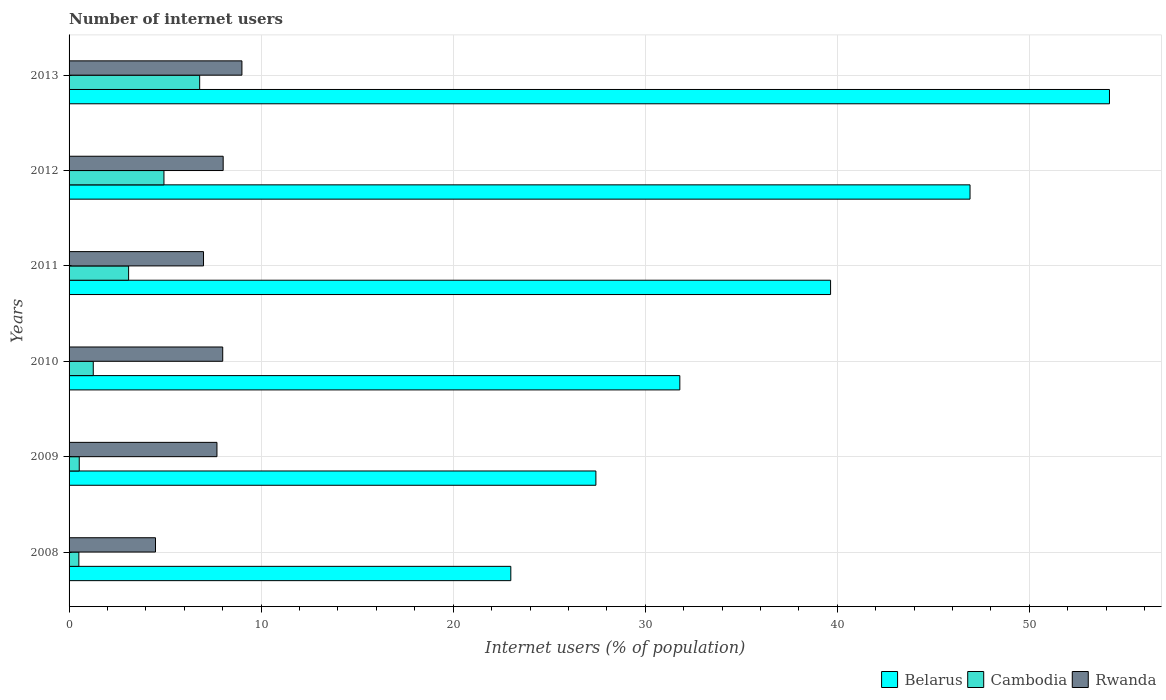How many groups of bars are there?
Provide a succinct answer. 6. Are the number of bars per tick equal to the number of legend labels?
Offer a very short reply. Yes. Are the number of bars on each tick of the Y-axis equal?
Give a very brief answer. Yes. What is the label of the 2nd group of bars from the top?
Offer a very short reply. 2012. What is the number of internet users in Belarus in 2008?
Provide a short and direct response. 23. Across all years, what is the maximum number of internet users in Cambodia?
Your answer should be very brief. 6.8. Across all years, what is the minimum number of internet users in Rwanda?
Give a very brief answer. 4.5. In which year was the number of internet users in Cambodia maximum?
Make the answer very short. 2013. What is the total number of internet users in Cambodia in the graph?
Ensure brevity in your answer.  17.14. What is the difference between the number of internet users in Cambodia in 2009 and that in 2013?
Offer a terse response. -6.27. What is the difference between the number of internet users in Belarus in 2010 and the number of internet users in Cambodia in 2011?
Give a very brief answer. 28.7. What is the average number of internet users in Belarus per year?
Offer a very short reply. 37.16. In the year 2009, what is the difference between the number of internet users in Belarus and number of internet users in Rwanda?
Make the answer very short. 19.73. In how many years, is the number of internet users in Cambodia greater than 46 %?
Keep it short and to the point. 0. What is the ratio of the number of internet users in Cambodia in 2008 to that in 2013?
Make the answer very short. 0.07. Is the difference between the number of internet users in Belarus in 2010 and 2011 greater than the difference between the number of internet users in Rwanda in 2010 and 2011?
Ensure brevity in your answer.  No. What is the difference between the highest and the second highest number of internet users in Belarus?
Provide a succinct answer. 7.26. What is the difference between the highest and the lowest number of internet users in Rwanda?
Offer a terse response. 4.5. In how many years, is the number of internet users in Rwanda greater than the average number of internet users in Rwanda taken over all years?
Ensure brevity in your answer.  4. Is the sum of the number of internet users in Rwanda in 2008 and 2012 greater than the maximum number of internet users in Cambodia across all years?
Provide a short and direct response. Yes. What does the 3rd bar from the top in 2013 represents?
Your response must be concise. Belarus. What does the 1st bar from the bottom in 2012 represents?
Offer a very short reply. Belarus. Is it the case that in every year, the sum of the number of internet users in Belarus and number of internet users in Rwanda is greater than the number of internet users in Cambodia?
Make the answer very short. Yes. What is the difference between two consecutive major ticks on the X-axis?
Your response must be concise. 10. Are the values on the major ticks of X-axis written in scientific E-notation?
Provide a succinct answer. No. Does the graph contain any zero values?
Your response must be concise. No. Does the graph contain grids?
Your answer should be very brief. Yes. Where does the legend appear in the graph?
Make the answer very short. Bottom right. How many legend labels are there?
Your answer should be very brief. 3. How are the legend labels stacked?
Your answer should be very brief. Horizontal. What is the title of the graph?
Keep it short and to the point. Number of internet users. What is the label or title of the X-axis?
Make the answer very short. Internet users (% of population). What is the label or title of the Y-axis?
Provide a short and direct response. Years. What is the Internet users (% of population) of Belarus in 2008?
Make the answer very short. 23. What is the Internet users (% of population) in Cambodia in 2008?
Offer a terse response. 0.51. What is the Internet users (% of population) of Rwanda in 2008?
Your response must be concise. 4.5. What is the Internet users (% of population) of Belarus in 2009?
Your answer should be compact. 27.43. What is the Internet users (% of population) in Cambodia in 2009?
Provide a short and direct response. 0.53. What is the Internet users (% of population) of Belarus in 2010?
Offer a very short reply. 31.8. What is the Internet users (% of population) of Cambodia in 2010?
Ensure brevity in your answer.  1.26. What is the Internet users (% of population) in Belarus in 2011?
Make the answer very short. 39.65. What is the Internet users (% of population) in Cambodia in 2011?
Offer a terse response. 3.1. What is the Internet users (% of population) in Belarus in 2012?
Keep it short and to the point. 46.91. What is the Internet users (% of population) in Cambodia in 2012?
Make the answer very short. 4.94. What is the Internet users (% of population) of Rwanda in 2012?
Offer a terse response. 8.02. What is the Internet users (% of population) in Belarus in 2013?
Your answer should be very brief. 54.17. What is the Internet users (% of population) in Cambodia in 2013?
Make the answer very short. 6.8. Across all years, what is the maximum Internet users (% of population) of Belarus?
Ensure brevity in your answer.  54.17. Across all years, what is the minimum Internet users (% of population) of Cambodia?
Your response must be concise. 0.51. Across all years, what is the minimum Internet users (% of population) of Rwanda?
Give a very brief answer. 4.5. What is the total Internet users (% of population) in Belarus in the graph?
Ensure brevity in your answer.  222.96. What is the total Internet users (% of population) in Cambodia in the graph?
Provide a succinct answer. 17.14. What is the total Internet users (% of population) in Rwanda in the graph?
Your answer should be compact. 44.22. What is the difference between the Internet users (% of population) in Belarus in 2008 and that in 2009?
Your response must be concise. -4.43. What is the difference between the Internet users (% of population) in Cambodia in 2008 and that in 2009?
Make the answer very short. -0.02. What is the difference between the Internet users (% of population) of Belarus in 2008 and that in 2010?
Ensure brevity in your answer.  -8.8. What is the difference between the Internet users (% of population) in Cambodia in 2008 and that in 2010?
Offer a very short reply. -0.75. What is the difference between the Internet users (% of population) in Belarus in 2008 and that in 2011?
Ensure brevity in your answer.  -16.65. What is the difference between the Internet users (% of population) in Cambodia in 2008 and that in 2011?
Keep it short and to the point. -2.59. What is the difference between the Internet users (% of population) of Rwanda in 2008 and that in 2011?
Offer a terse response. -2.5. What is the difference between the Internet users (% of population) in Belarus in 2008 and that in 2012?
Your answer should be very brief. -23.91. What is the difference between the Internet users (% of population) of Cambodia in 2008 and that in 2012?
Keep it short and to the point. -4.43. What is the difference between the Internet users (% of population) in Rwanda in 2008 and that in 2012?
Your answer should be compact. -3.52. What is the difference between the Internet users (% of population) of Belarus in 2008 and that in 2013?
Provide a succinct answer. -31.17. What is the difference between the Internet users (% of population) of Cambodia in 2008 and that in 2013?
Offer a very short reply. -6.29. What is the difference between the Internet users (% of population) of Belarus in 2009 and that in 2010?
Keep it short and to the point. -4.37. What is the difference between the Internet users (% of population) in Cambodia in 2009 and that in 2010?
Your answer should be compact. -0.73. What is the difference between the Internet users (% of population) in Belarus in 2009 and that in 2011?
Your answer should be compact. -12.22. What is the difference between the Internet users (% of population) in Cambodia in 2009 and that in 2011?
Offer a terse response. -2.57. What is the difference between the Internet users (% of population) of Belarus in 2009 and that in 2012?
Your answer should be compact. -19.48. What is the difference between the Internet users (% of population) in Cambodia in 2009 and that in 2012?
Your answer should be compact. -4.41. What is the difference between the Internet users (% of population) of Rwanda in 2009 and that in 2012?
Provide a succinct answer. -0.32. What is the difference between the Internet users (% of population) of Belarus in 2009 and that in 2013?
Ensure brevity in your answer.  -26.74. What is the difference between the Internet users (% of population) in Cambodia in 2009 and that in 2013?
Your answer should be very brief. -6.27. What is the difference between the Internet users (% of population) in Belarus in 2010 and that in 2011?
Offer a terse response. -7.85. What is the difference between the Internet users (% of population) in Cambodia in 2010 and that in 2011?
Make the answer very short. -1.84. What is the difference between the Internet users (% of population) of Belarus in 2010 and that in 2012?
Your response must be concise. -15.11. What is the difference between the Internet users (% of population) of Cambodia in 2010 and that in 2012?
Keep it short and to the point. -3.68. What is the difference between the Internet users (% of population) in Rwanda in 2010 and that in 2012?
Your response must be concise. -0.02. What is the difference between the Internet users (% of population) of Belarus in 2010 and that in 2013?
Offer a very short reply. -22.37. What is the difference between the Internet users (% of population) of Cambodia in 2010 and that in 2013?
Your answer should be very brief. -5.54. What is the difference between the Internet users (% of population) of Belarus in 2011 and that in 2012?
Make the answer very short. -7.26. What is the difference between the Internet users (% of population) in Cambodia in 2011 and that in 2012?
Ensure brevity in your answer.  -1.84. What is the difference between the Internet users (% of population) in Rwanda in 2011 and that in 2012?
Ensure brevity in your answer.  -1.02. What is the difference between the Internet users (% of population) in Belarus in 2011 and that in 2013?
Provide a succinct answer. -14.52. What is the difference between the Internet users (% of population) of Cambodia in 2011 and that in 2013?
Give a very brief answer. -3.7. What is the difference between the Internet users (% of population) of Rwanda in 2011 and that in 2013?
Give a very brief answer. -2. What is the difference between the Internet users (% of population) of Belarus in 2012 and that in 2013?
Offer a terse response. -7.26. What is the difference between the Internet users (% of population) of Cambodia in 2012 and that in 2013?
Give a very brief answer. -1.86. What is the difference between the Internet users (% of population) of Rwanda in 2012 and that in 2013?
Keep it short and to the point. -0.98. What is the difference between the Internet users (% of population) of Belarus in 2008 and the Internet users (% of population) of Cambodia in 2009?
Provide a succinct answer. 22.47. What is the difference between the Internet users (% of population) in Belarus in 2008 and the Internet users (% of population) in Rwanda in 2009?
Give a very brief answer. 15.3. What is the difference between the Internet users (% of population) in Cambodia in 2008 and the Internet users (% of population) in Rwanda in 2009?
Ensure brevity in your answer.  -7.19. What is the difference between the Internet users (% of population) in Belarus in 2008 and the Internet users (% of population) in Cambodia in 2010?
Keep it short and to the point. 21.74. What is the difference between the Internet users (% of population) in Belarus in 2008 and the Internet users (% of population) in Rwanda in 2010?
Ensure brevity in your answer.  15. What is the difference between the Internet users (% of population) in Cambodia in 2008 and the Internet users (% of population) in Rwanda in 2010?
Keep it short and to the point. -7.49. What is the difference between the Internet users (% of population) of Belarus in 2008 and the Internet users (% of population) of Rwanda in 2011?
Ensure brevity in your answer.  16. What is the difference between the Internet users (% of population) in Cambodia in 2008 and the Internet users (% of population) in Rwanda in 2011?
Ensure brevity in your answer.  -6.49. What is the difference between the Internet users (% of population) in Belarus in 2008 and the Internet users (% of population) in Cambodia in 2012?
Your response must be concise. 18.06. What is the difference between the Internet users (% of population) in Belarus in 2008 and the Internet users (% of population) in Rwanda in 2012?
Ensure brevity in your answer.  14.98. What is the difference between the Internet users (% of population) of Cambodia in 2008 and the Internet users (% of population) of Rwanda in 2012?
Your answer should be compact. -7.51. What is the difference between the Internet users (% of population) of Cambodia in 2008 and the Internet users (% of population) of Rwanda in 2013?
Provide a succinct answer. -8.49. What is the difference between the Internet users (% of population) in Belarus in 2009 and the Internet users (% of population) in Cambodia in 2010?
Give a very brief answer. 26.17. What is the difference between the Internet users (% of population) of Belarus in 2009 and the Internet users (% of population) of Rwanda in 2010?
Keep it short and to the point. 19.43. What is the difference between the Internet users (% of population) in Cambodia in 2009 and the Internet users (% of population) in Rwanda in 2010?
Offer a terse response. -7.47. What is the difference between the Internet users (% of population) in Belarus in 2009 and the Internet users (% of population) in Cambodia in 2011?
Your response must be concise. 24.33. What is the difference between the Internet users (% of population) of Belarus in 2009 and the Internet users (% of population) of Rwanda in 2011?
Your response must be concise. 20.43. What is the difference between the Internet users (% of population) in Cambodia in 2009 and the Internet users (% of population) in Rwanda in 2011?
Provide a succinct answer. -6.47. What is the difference between the Internet users (% of population) of Belarus in 2009 and the Internet users (% of population) of Cambodia in 2012?
Your response must be concise. 22.49. What is the difference between the Internet users (% of population) of Belarus in 2009 and the Internet users (% of population) of Rwanda in 2012?
Your answer should be very brief. 19.41. What is the difference between the Internet users (% of population) of Cambodia in 2009 and the Internet users (% of population) of Rwanda in 2012?
Your answer should be very brief. -7.49. What is the difference between the Internet users (% of population) in Belarus in 2009 and the Internet users (% of population) in Cambodia in 2013?
Make the answer very short. 20.63. What is the difference between the Internet users (% of population) of Belarus in 2009 and the Internet users (% of population) of Rwanda in 2013?
Make the answer very short. 18.43. What is the difference between the Internet users (% of population) in Cambodia in 2009 and the Internet users (% of population) in Rwanda in 2013?
Provide a succinct answer. -8.47. What is the difference between the Internet users (% of population) of Belarus in 2010 and the Internet users (% of population) of Cambodia in 2011?
Provide a short and direct response. 28.7. What is the difference between the Internet users (% of population) in Belarus in 2010 and the Internet users (% of population) in Rwanda in 2011?
Provide a short and direct response. 24.8. What is the difference between the Internet users (% of population) in Cambodia in 2010 and the Internet users (% of population) in Rwanda in 2011?
Ensure brevity in your answer.  -5.74. What is the difference between the Internet users (% of population) in Belarus in 2010 and the Internet users (% of population) in Cambodia in 2012?
Make the answer very short. 26.86. What is the difference between the Internet users (% of population) of Belarus in 2010 and the Internet users (% of population) of Rwanda in 2012?
Offer a very short reply. 23.78. What is the difference between the Internet users (% of population) of Cambodia in 2010 and the Internet users (% of population) of Rwanda in 2012?
Make the answer very short. -6.76. What is the difference between the Internet users (% of population) of Belarus in 2010 and the Internet users (% of population) of Cambodia in 2013?
Your response must be concise. 25. What is the difference between the Internet users (% of population) in Belarus in 2010 and the Internet users (% of population) in Rwanda in 2013?
Provide a short and direct response. 22.8. What is the difference between the Internet users (% of population) of Cambodia in 2010 and the Internet users (% of population) of Rwanda in 2013?
Provide a short and direct response. -7.74. What is the difference between the Internet users (% of population) in Belarus in 2011 and the Internet users (% of population) in Cambodia in 2012?
Make the answer very short. 34.71. What is the difference between the Internet users (% of population) of Belarus in 2011 and the Internet users (% of population) of Rwanda in 2012?
Your response must be concise. 31.62. What is the difference between the Internet users (% of population) in Cambodia in 2011 and the Internet users (% of population) in Rwanda in 2012?
Keep it short and to the point. -4.92. What is the difference between the Internet users (% of population) in Belarus in 2011 and the Internet users (% of population) in Cambodia in 2013?
Offer a terse response. 32.85. What is the difference between the Internet users (% of population) in Belarus in 2011 and the Internet users (% of population) in Rwanda in 2013?
Offer a terse response. 30.65. What is the difference between the Internet users (% of population) in Belarus in 2012 and the Internet users (% of population) in Cambodia in 2013?
Your response must be concise. 40.11. What is the difference between the Internet users (% of population) in Belarus in 2012 and the Internet users (% of population) in Rwanda in 2013?
Give a very brief answer. 37.91. What is the difference between the Internet users (% of population) of Cambodia in 2012 and the Internet users (% of population) of Rwanda in 2013?
Make the answer very short. -4.06. What is the average Internet users (% of population) in Belarus per year?
Your answer should be very brief. 37.16. What is the average Internet users (% of population) of Cambodia per year?
Offer a terse response. 2.86. What is the average Internet users (% of population) of Rwanda per year?
Offer a very short reply. 7.37. In the year 2008, what is the difference between the Internet users (% of population) in Belarus and Internet users (% of population) in Cambodia?
Make the answer very short. 22.49. In the year 2008, what is the difference between the Internet users (% of population) of Cambodia and Internet users (% of population) of Rwanda?
Ensure brevity in your answer.  -3.99. In the year 2009, what is the difference between the Internet users (% of population) of Belarus and Internet users (% of population) of Cambodia?
Keep it short and to the point. 26.9. In the year 2009, what is the difference between the Internet users (% of population) of Belarus and Internet users (% of population) of Rwanda?
Provide a short and direct response. 19.73. In the year 2009, what is the difference between the Internet users (% of population) of Cambodia and Internet users (% of population) of Rwanda?
Provide a short and direct response. -7.17. In the year 2010, what is the difference between the Internet users (% of population) in Belarus and Internet users (% of population) in Cambodia?
Give a very brief answer. 30.54. In the year 2010, what is the difference between the Internet users (% of population) of Belarus and Internet users (% of population) of Rwanda?
Provide a short and direct response. 23.8. In the year 2010, what is the difference between the Internet users (% of population) in Cambodia and Internet users (% of population) in Rwanda?
Offer a very short reply. -6.74. In the year 2011, what is the difference between the Internet users (% of population) of Belarus and Internet users (% of population) of Cambodia?
Your response must be concise. 36.55. In the year 2011, what is the difference between the Internet users (% of population) of Belarus and Internet users (% of population) of Rwanda?
Offer a terse response. 32.65. In the year 2011, what is the difference between the Internet users (% of population) in Cambodia and Internet users (% of population) in Rwanda?
Provide a short and direct response. -3.9. In the year 2012, what is the difference between the Internet users (% of population) in Belarus and Internet users (% of population) in Cambodia?
Your answer should be very brief. 41.97. In the year 2012, what is the difference between the Internet users (% of population) of Belarus and Internet users (% of population) of Rwanda?
Your answer should be compact. 38.89. In the year 2012, what is the difference between the Internet users (% of population) in Cambodia and Internet users (% of population) in Rwanda?
Provide a short and direct response. -3.08. In the year 2013, what is the difference between the Internet users (% of population) in Belarus and Internet users (% of population) in Cambodia?
Provide a succinct answer. 47.37. In the year 2013, what is the difference between the Internet users (% of population) of Belarus and Internet users (% of population) of Rwanda?
Offer a very short reply. 45.17. In the year 2013, what is the difference between the Internet users (% of population) in Cambodia and Internet users (% of population) in Rwanda?
Provide a short and direct response. -2.2. What is the ratio of the Internet users (% of population) of Belarus in 2008 to that in 2009?
Provide a short and direct response. 0.84. What is the ratio of the Internet users (% of population) in Cambodia in 2008 to that in 2009?
Your answer should be very brief. 0.96. What is the ratio of the Internet users (% of population) of Rwanda in 2008 to that in 2009?
Offer a very short reply. 0.58. What is the ratio of the Internet users (% of population) of Belarus in 2008 to that in 2010?
Make the answer very short. 0.72. What is the ratio of the Internet users (% of population) in Cambodia in 2008 to that in 2010?
Your answer should be compact. 0.4. What is the ratio of the Internet users (% of population) of Rwanda in 2008 to that in 2010?
Ensure brevity in your answer.  0.56. What is the ratio of the Internet users (% of population) in Belarus in 2008 to that in 2011?
Provide a succinct answer. 0.58. What is the ratio of the Internet users (% of population) of Cambodia in 2008 to that in 2011?
Give a very brief answer. 0.16. What is the ratio of the Internet users (% of population) of Rwanda in 2008 to that in 2011?
Offer a very short reply. 0.64. What is the ratio of the Internet users (% of population) of Belarus in 2008 to that in 2012?
Provide a short and direct response. 0.49. What is the ratio of the Internet users (% of population) in Cambodia in 2008 to that in 2012?
Provide a short and direct response. 0.1. What is the ratio of the Internet users (% of population) in Rwanda in 2008 to that in 2012?
Provide a short and direct response. 0.56. What is the ratio of the Internet users (% of population) of Belarus in 2008 to that in 2013?
Give a very brief answer. 0.42. What is the ratio of the Internet users (% of population) in Cambodia in 2008 to that in 2013?
Give a very brief answer. 0.07. What is the ratio of the Internet users (% of population) in Belarus in 2009 to that in 2010?
Your answer should be very brief. 0.86. What is the ratio of the Internet users (% of population) of Cambodia in 2009 to that in 2010?
Give a very brief answer. 0.42. What is the ratio of the Internet users (% of population) of Rwanda in 2009 to that in 2010?
Give a very brief answer. 0.96. What is the ratio of the Internet users (% of population) in Belarus in 2009 to that in 2011?
Give a very brief answer. 0.69. What is the ratio of the Internet users (% of population) in Cambodia in 2009 to that in 2011?
Make the answer very short. 0.17. What is the ratio of the Internet users (% of population) in Rwanda in 2009 to that in 2011?
Make the answer very short. 1.1. What is the ratio of the Internet users (% of population) of Belarus in 2009 to that in 2012?
Your answer should be compact. 0.58. What is the ratio of the Internet users (% of population) in Cambodia in 2009 to that in 2012?
Provide a short and direct response. 0.11. What is the ratio of the Internet users (% of population) of Rwanda in 2009 to that in 2012?
Offer a very short reply. 0.96. What is the ratio of the Internet users (% of population) in Belarus in 2009 to that in 2013?
Your response must be concise. 0.51. What is the ratio of the Internet users (% of population) of Cambodia in 2009 to that in 2013?
Your answer should be very brief. 0.08. What is the ratio of the Internet users (% of population) in Rwanda in 2009 to that in 2013?
Make the answer very short. 0.86. What is the ratio of the Internet users (% of population) in Belarus in 2010 to that in 2011?
Your answer should be very brief. 0.8. What is the ratio of the Internet users (% of population) in Cambodia in 2010 to that in 2011?
Offer a very short reply. 0.41. What is the ratio of the Internet users (% of population) of Belarus in 2010 to that in 2012?
Ensure brevity in your answer.  0.68. What is the ratio of the Internet users (% of population) in Cambodia in 2010 to that in 2012?
Make the answer very short. 0.26. What is the ratio of the Internet users (% of population) in Belarus in 2010 to that in 2013?
Provide a short and direct response. 0.59. What is the ratio of the Internet users (% of population) of Cambodia in 2010 to that in 2013?
Your answer should be compact. 0.19. What is the ratio of the Internet users (% of population) in Belarus in 2011 to that in 2012?
Keep it short and to the point. 0.85. What is the ratio of the Internet users (% of population) in Cambodia in 2011 to that in 2012?
Offer a terse response. 0.63. What is the ratio of the Internet users (% of population) in Rwanda in 2011 to that in 2012?
Your answer should be very brief. 0.87. What is the ratio of the Internet users (% of population) in Belarus in 2011 to that in 2013?
Offer a terse response. 0.73. What is the ratio of the Internet users (% of population) of Cambodia in 2011 to that in 2013?
Keep it short and to the point. 0.46. What is the ratio of the Internet users (% of population) in Belarus in 2012 to that in 2013?
Your answer should be very brief. 0.87. What is the ratio of the Internet users (% of population) in Cambodia in 2012 to that in 2013?
Your answer should be compact. 0.73. What is the ratio of the Internet users (% of population) in Rwanda in 2012 to that in 2013?
Ensure brevity in your answer.  0.89. What is the difference between the highest and the second highest Internet users (% of population) of Belarus?
Your answer should be compact. 7.26. What is the difference between the highest and the second highest Internet users (% of population) of Cambodia?
Keep it short and to the point. 1.86. What is the difference between the highest and the second highest Internet users (% of population) of Rwanda?
Offer a very short reply. 0.98. What is the difference between the highest and the lowest Internet users (% of population) of Belarus?
Your answer should be compact. 31.17. What is the difference between the highest and the lowest Internet users (% of population) in Cambodia?
Give a very brief answer. 6.29. 